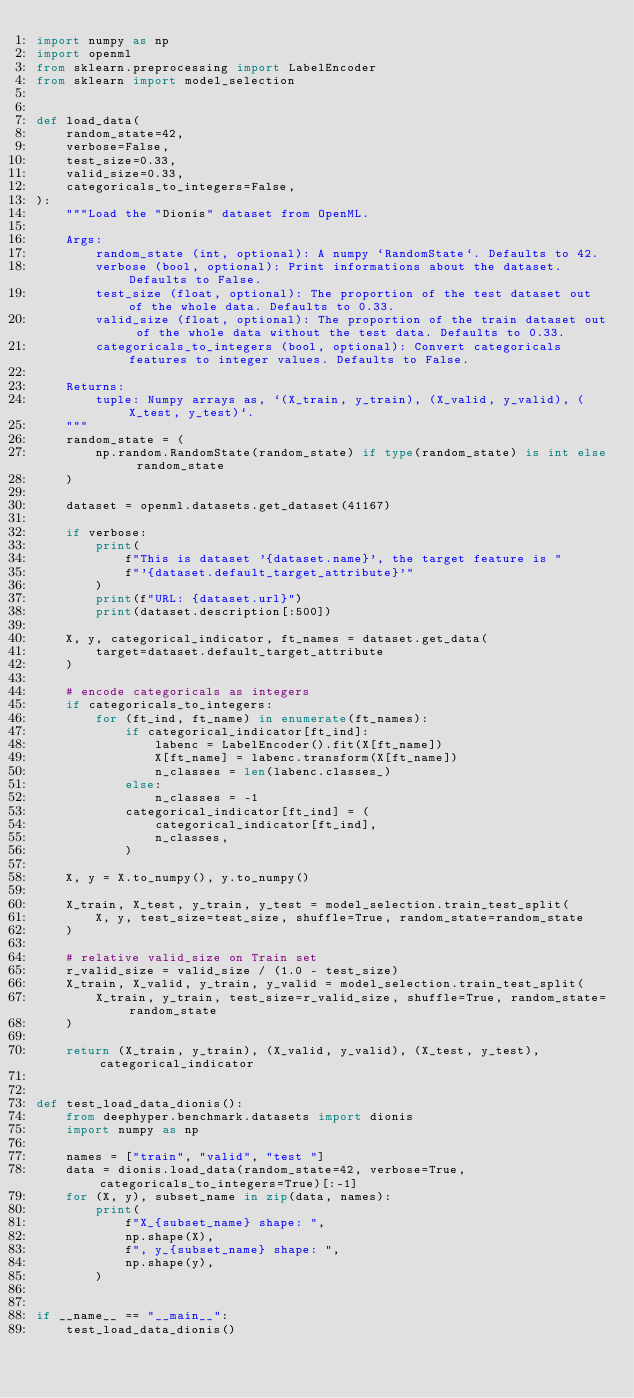<code> <loc_0><loc_0><loc_500><loc_500><_Python_>import numpy as np
import openml
from sklearn.preprocessing import LabelEncoder
from sklearn import model_selection


def load_data(
    random_state=42,
    verbose=False,
    test_size=0.33,
    valid_size=0.33,
    categoricals_to_integers=False,
):
    """Load the "Dionis" dataset from OpenML.

    Args:
        random_state (int, optional): A numpy `RandomState`. Defaults to 42.
        verbose (bool, optional): Print informations about the dataset. Defaults to False.
        test_size (float, optional): The proportion of the test dataset out of the whole data. Defaults to 0.33.
        valid_size (float, optional): The proportion of the train dataset out of the whole data without the test data. Defaults to 0.33.
        categoricals_to_integers (bool, optional): Convert categoricals features to integer values. Defaults to False.

    Returns:
        tuple: Numpy arrays as, `(X_train, y_train), (X_valid, y_valid), (X_test, y_test)`.
    """
    random_state = (
        np.random.RandomState(random_state) if type(random_state) is int else random_state
    )

    dataset = openml.datasets.get_dataset(41167)

    if verbose:
        print(
            f"This is dataset '{dataset.name}', the target feature is "
            f"'{dataset.default_target_attribute}'"
        )
        print(f"URL: {dataset.url}")
        print(dataset.description[:500])

    X, y, categorical_indicator, ft_names = dataset.get_data(
        target=dataset.default_target_attribute
    )

    # encode categoricals as integers
    if categoricals_to_integers:
        for (ft_ind, ft_name) in enumerate(ft_names):
            if categorical_indicator[ft_ind]:
                labenc = LabelEncoder().fit(X[ft_name])
                X[ft_name] = labenc.transform(X[ft_name])
                n_classes = len(labenc.classes_)
            else:
                n_classes = -1
            categorical_indicator[ft_ind] = (
                categorical_indicator[ft_ind],
                n_classes,
            )

    X, y = X.to_numpy(), y.to_numpy()

    X_train, X_test, y_train, y_test = model_selection.train_test_split(
        X, y, test_size=test_size, shuffle=True, random_state=random_state
    )

    # relative valid_size on Train set
    r_valid_size = valid_size / (1.0 - test_size)
    X_train, X_valid, y_train, y_valid = model_selection.train_test_split(
        X_train, y_train, test_size=r_valid_size, shuffle=True, random_state=random_state
    )

    return (X_train, y_train), (X_valid, y_valid), (X_test, y_test), categorical_indicator


def test_load_data_dionis():
    from deephyper.benchmark.datasets import dionis
    import numpy as np

    names = ["train", "valid", "test "]
    data = dionis.load_data(random_state=42, verbose=True, categoricals_to_integers=True)[:-1]
    for (X, y), subset_name in zip(data, names):
        print(
            f"X_{subset_name} shape: ",
            np.shape(X),
            f", y_{subset_name} shape: ",
            np.shape(y),
        )


if __name__ == "__main__":
    test_load_data_dionis()
</code> 